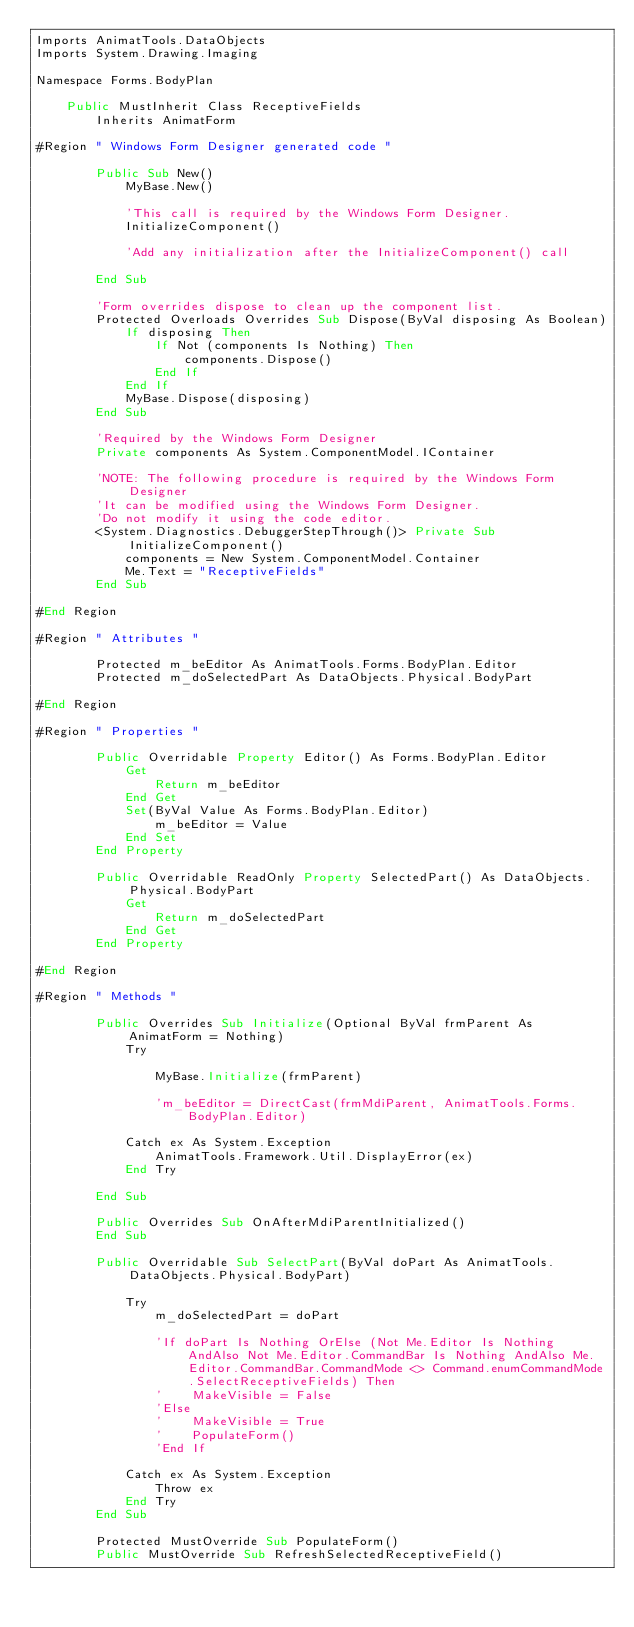<code> <loc_0><loc_0><loc_500><loc_500><_VisualBasic_>Imports AnimatTools.DataObjects
Imports System.Drawing.Imaging

Namespace Forms.BodyPlan

    Public MustInherit Class ReceptiveFields
        Inherits AnimatForm

#Region " Windows Form Designer generated code "

        Public Sub New()
            MyBase.New()

            'This call is required by the Windows Form Designer.
            InitializeComponent()

            'Add any initialization after the InitializeComponent() call

        End Sub

        'Form overrides dispose to clean up the component list.
        Protected Overloads Overrides Sub Dispose(ByVal disposing As Boolean)
            If disposing Then
                If Not (components Is Nothing) Then
                    components.Dispose()
                End If
            End If
            MyBase.Dispose(disposing)
        End Sub

        'Required by the Windows Form Designer
        Private components As System.ComponentModel.IContainer

        'NOTE: The following procedure is required by the Windows Form Designer
        'It can be modified using the Windows Form Designer.  
        'Do not modify it using the code editor.
        <System.Diagnostics.DebuggerStepThrough()> Private Sub InitializeComponent()
            components = New System.ComponentModel.Container
            Me.Text = "ReceptiveFields"
        End Sub

#End Region

#Region " Attributes "

        Protected m_beEditor As AnimatTools.Forms.BodyPlan.Editor
        Protected m_doSelectedPart As DataObjects.Physical.BodyPart

#End Region

#Region " Properties "

        Public Overridable Property Editor() As Forms.BodyPlan.Editor
            Get
                Return m_beEditor
            End Get
            Set(ByVal Value As Forms.BodyPlan.Editor)
                m_beEditor = Value
            End Set
        End Property

        Public Overridable ReadOnly Property SelectedPart() As DataObjects.Physical.BodyPart
            Get
                Return m_doSelectedPart
            End Get
        End Property

#End Region

#Region " Methods "

        Public Overrides Sub Initialize(Optional ByVal frmParent As AnimatForm = Nothing)
            Try

                MyBase.Initialize(frmParent)

                'm_beEditor = DirectCast(frmMdiParent, AnimatTools.Forms.BodyPlan.Editor)

            Catch ex As System.Exception
                AnimatTools.Framework.Util.DisplayError(ex)
            End Try

        End Sub

        Public Overrides Sub OnAfterMdiParentInitialized()
        End Sub

        Public Overridable Sub SelectPart(ByVal doPart As AnimatTools.DataObjects.Physical.BodyPart)

            Try
                m_doSelectedPart = doPart

                'If doPart Is Nothing OrElse (Not Me.Editor Is Nothing AndAlso Not Me.Editor.CommandBar Is Nothing AndAlso Me.Editor.CommandBar.CommandMode <> Command.enumCommandMode.SelectReceptiveFields) Then
                '    MakeVisible = False
                'Else
                '    MakeVisible = True
                '    PopulateForm()
                'End If

            Catch ex As System.Exception
                Throw ex
            End Try
        End Sub

        Protected MustOverride Sub PopulateForm()
        Public MustOverride Sub RefreshSelectedReceptiveField()
</code> 